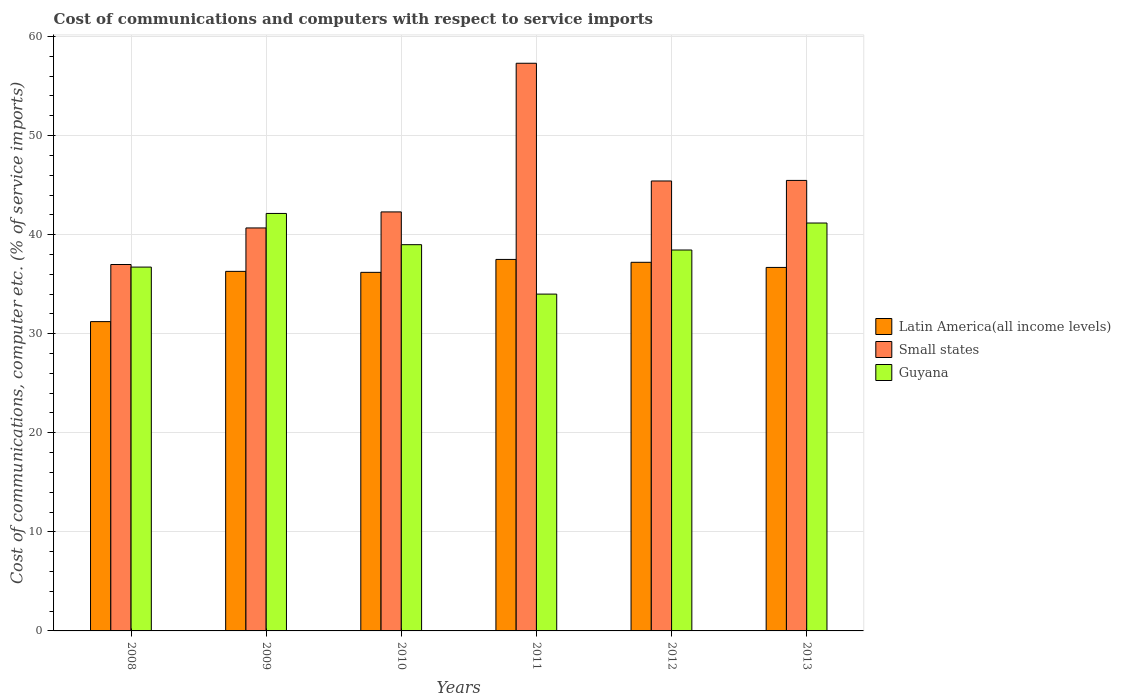How many different coloured bars are there?
Offer a very short reply. 3. How many bars are there on the 6th tick from the left?
Provide a short and direct response. 3. In how many cases, is the number of bars for a given year not equal to the number of legend labels?
Offer a terse response. 0. What is the cost of communications and computers in Guyana in 2013?
Offer a very short reply. 41.17. Across all years, what is the maximum cost of communications and computers in Latin America(all income levels)?
Ensure brevity in your answer.  37.5. Across all years, what is the minimum cost of communications and computers in Latin America(all income levels)?
Offer a very short reply. 31.22. In which year was the cost of communications and computers in Small states minimum?
Make the answer very short. 2008. What is the total cost of communications and computers in Small states in the graph?
Give a very brief answer. 268.16. What is the difference between the cost of communications and computers in Latin America(all income levels) in 2009 and that in 2011?
Your answer should be very brief. -1.2. What is the difference between the cost of communications and computers in Small states in 2012 and the cost of communications and computers in Guyana in 2013?
Your answer should be very brief. 4.24. What is the average cost of communications and computers in Latin America(all income levels) per year?
Offer a terse response. 35.85. In the year 2009, what is the difference between the cost of communications and computers in Latin America(all income levels) and cost of communications and computers in Guyana?
Make the answer very short. -5.85. In how many years, is the cost of communications and computers in Guyana greater than 10 %?
Offer a very short reply. 6. What is the ratio of the cost of communications and computers in Latin America(all income levels) in 2008 to that in 2011?
Give a very brief answer. 0.83. Is the cost of communications and computers in Guyana in 2010 less than that in 2011?
Make the answer very short. No. What is the difference between the highest and the second highest cost of communications and computers in Small states?
Offer a terse response. 11.83. What is the difference between the highest and the lowest cost of communications and computers in Guyana?
Offer a terse response. 8.14. In how many years, is the cost of communications and computers in Guyana greater than the average cost of communications and computers in Guyana taken over all years?
Your response must be concise. 3. Is the sum of the cost of communications and computers in Small states in 2011 and 2012 greater than the maximum cost of communications and computers in Latin America(all income levels) across all years?
Provide a succinct answer. Yes. What does the 1st bar from the left in 2009 represents?
Keep it short and to the point. Latin America(all income levels). What does the 3rd bar from the right in 2013 represents?
Keep it short and to the point. Latin America(all income levels). Is it the case that in every year, the sum of the cost of communications and computers in Latin America(all income levels) and cost of communications and computers in Small states is greater than the cost of communications and computers in Guyana?
Your answer should be very brief. Yes. Are all the bars in the graph horizontal?
Offer a terse response. No. How many years are there in the graph?
Your answer should be very brief. 6. Are the values on the major ticks of Y-axis written in scientific E-notation?
Offer a very short reply. No. How many legend labels are there?
Your answer should be very brief. 3. What is the title of the graph?
Offer a very short reply. Cost of communications and computers with respect to service imports. Does "Malaysia" appear as one of the legend labels in the graph?
Make the answer very short. No. What is the label or title of the X-axis?
Keep it short and to the point. Years. What is the label or title of the Y-axis?
Give a very brief answer. Cost of communications, computer etc. (% of service imports). What is the Cost of communications, computer etc. (% of service imports) in Latin America(all income levels) in 2008?
Make the answer very short. 31.22. What is the Cost of communications, computer etc. (% of service imports) in Small states in 2008?
Your answer should be compact. 36.99. What is the Cost of communications, computer etc. (% of service imports) in Guyana in 2008?
Offer a very short reply. 36.73. What is the Cost of communications, computer etc. (% of service imports) of Latin America(all income levels) in 2009?
Your answer should be very brief. 36.3. What is the Cost of communications, computer etc. (% of service imports) of Small states in 2009?
Provide a short and direct response. 40.68. What is the Cost of communications, computer etc. (% of service imports) of Guyana in 2009?
Ensure brevity in your answer.  42.14. What is the Cost of communications, computer etc. (% of service imports) of Latin America(all income levels) in 2010?
Provide a short and direct response. 36.2. What is the Cost of communications, computer etc. (% of service imports) in Small states in 2010?
Your answer should be very brief. 42.3. What is the Cost of communications, computer etc. (% of service imports) of Guyana in 2010?
Your answer should be very brief. 38.99. What is the Cost of communications, computer etc. (% of service imports) of Latin America(all income levels) in 2011?
Your response must be concise. 37.5. What is the Cost of communications, computer etc. (% of service imports) of Small states in 2011?
Your answer should be very brief. 57.3. What is the Cost of communications, computer etc. (% of service imports) of Guyana in 2011?
Your answer should be very brief. 34. What is the Cost of communications, computer etc. (% of service imports) in Latin America(all income levels) in 2012?
Your answer should be compact. 37.21. What is the Cost of communications, computer etc. (% of service imports) of Small states in 2012?
Your answer should be very brief. 45.42. What is the Cost of communications, computer etc. (% of service imports) in Guyana in 2012?
Provide a short and direct response. 38.45. What is the Cost of communications, computer etc. (% of service imports) in Latin America(all income levels) in 2013?
Ensure brevity in your answer.  36.69. What is the Cost of communications, computer etc. (% of service imports) of Small states in 2013?
Your answer should be very brief. 45.48. What is the Cost of communications, computer etc. (% of service imports) in Guyana in 2013?
Provide a succinct answer. 41.17. Across all years, what is the maximum Cost of communications, computer etc. (% of service imports) in Latin America(all income levels)?
Make the answer very short. 37.5. Across all years, what is the maximum Cost of communications, computer etc. (% of service imports) in Small states?
Make the answer very short. 57.3. Across all years, what is the maximum Cost of communications, computer etc. (% of service imports) in Guyana?
Provide a short and direct response. 42.14. Across all years, what is the minimum Cost of communications, computer etc. (% of service imports) in Latin America(all income levels)?
Keep it short and to the point. 31.22. Across all years, what is the minimum Cost of communications, computer etc. (% of service imports) in Small states?
Make the answer very short. 36.99. Across all years, what is the minimum Cost of communications, computer etc. (% of service imports) of Guyana?
Your response must be concise. 34. What is the total Cost of communications, computer etc. (% of service imports) of Latin America(all income levels) in the graph?
Provide a short and direct response. 215.12. What is the total Cost of communications, computer etc. (% of service imports) in Small states in the graph?
Offer a very short reply. 268.16. What is the total Cost of communications, computer etc. (% of service imports) in Guyana in the graph?
Your answer should be compact. 231.48. What is the difference between the Cost of communications, computer etc. (% of service imports) in Latin America(all income levels) in 2008 and that in 2009?
Make the answer very short. -5.07. What is the difference between the Cost of communications, computer etc. (% of service imports) of Small states in 2008 and that in 2009?
Provide a short and direct response. -3.69. What is the difference between the Cost of communications, computer etc. (% of service imports) in Guyana in 2008 and that in 2009?
Provide a short and direct response. -5.42. What is the difference between the Cost of communications, computer etc. (% of service imports) of Latin America(all income levels) in 2008 and that in 2010?
Offer a very short reply. -4.97. What is the difference between the Cost of communications, computer etc. (% of service imports) of Small states in 2008 and that in 2010?
Provide a succinct answer. -5.31. What is the difference between the Cost of communications, computer etc. (% of service imports) of Guyana in 2008 and that in 2010?
Your response must be concise. -2.26. What is the difference between the Cost of communications, computer etc. (% of service imports) of Latin America(all income levels) in 2008 and that in 2011?
Provide a short and direct response. -6.28. What is the difference between the Cost of communications, computer etc. (% of service imports) of Small states in 2008 and that in 2011?
Keep it short and to the point. -20.31. What is the difference between the Cost of communications, computer etc. (% of service imports) of Guyana in 2008 and that in 2011?
Make the answer very short. 2.73. What is the difference between the Cost of communications, computer etc. (% of service imports) of Latin America(all income levels) in 2008 and that in 2012?
Your answer should be very brief. -5.99. What is the difference between the Cost of communications, computer etc. (% of service imports) in Small states in 2008 and that in 2012?
Offer a terse response. -8.43. What is the difference between the Cost of communications, computer etc. (% of service imports) of Guyana in 2008 and that in 2012?
Your response must be concise. -1.72. What is the difference between the Cost of communications, computer etc. (% of service imports) of Latin America(all income levels) in 2008 and that in 2013?
Give a very brief answer. -5.47. What is the difference between the Cost of communications, computer etc. (% of service imports) of Small states in 2008 and that in 2013?
Provide a succinct answer. -8.49. What is the difference between the Cost of communications, computer etc. (% of service imports) of Guyana in 2008 and that in 2013?
Your answer should be compact. -4.45. What is the difference between the Cost of communications, computer etc. (% of service imports) in Latin America(all income levels) in 2009 and that in 2010?
Provide a short and direct response. 0.1. What is the difference between the Cost of communications, computer etc. (% of service imports) of Small states in 2009 and that in 2010?
Your response must be concise. -1.62. What is the difference between the Cost of communications, computer etc. (% of service imports) of Guyana in 2009 and that in 2010?
Provide a succinct answer. 3.15. What is the difference between the Cost of communications, computer etc. (% of service imports) in Latin America(all income levels) in 2009 and that in 2011?
Provide a succinct answer. -1.2. What is the difference between the Cost of communications, computer etc. (% of service imports) in Small states in 2009 and that in 2011?
Offer a terse response. -16.62. What is the difference between the Cost of communications, computer etc. (% of service imports) in Guyana in 2009 and that in 2011?
Make the answer very short. 8.14. What is the difference between the Cost of communications, computer etc. (% of service imports) of Latin America(all income levels) in 2009 and that in 2012?
Provide a short and direct response. -0.91. What is the difference between the Cost of communications, computer etc. (% of service imports) in Small states in 2009 and that in 2012?
Ensure brevity in your answer.  -4.74. What is the difference between the Cost of communications, computer etc. (% of service imports) in Guyana in 2009 and that in 2012?
Your answer should be very brief. 3.69. What is the difference between the Cost of communications, computer etc. (% of service imports) in Latin America(all income levels) in 2009 and that in 2013?
Provide a short and direct response. -0.4. What is the difference between the Cost of communications, computer etc. (% of service imports) in Small states in 2009 and that in 2013?
Offer a terse response. -4.8. What is the difference between the Cost of communications, computer etc. (% of service imports) of Guyana in 2009 and that in 2013?
Provide a short and direct response. 0.97. What is the difference between the Cost of communications, computer etc. (% of service imports) of Latin America(all income levels) in 2010 and that in 2011?
Provide a short and direct response. -1.3. What is the difference between the Cost of communications, computer etc. (% of service imports) of Small states in 2010 and that in 2011?
Your answer should be compact. -15.01. What is the difference between the Cost of communications, computer etc. (% of service imports) in Guyana in 2010 and that in 2011?
Offer a terse response. 4.99. What is the difference between the Cost of communications, computer etc. (% of service imports) of Latin America(all income levels) in 2010 and that in 2012?
Offer a terse response. -1.01. What is the difference between the Cost of communications, computer etc. (% of service imports) of Small states in 2010 and that in 2012?
Keep it short and to the point. -3.12. What is the difference between the Cost of communications, computer etc. (% of service imports) in Guyana in 2010 and that in 2012?
Your answer should be compact. 0.54. What is the difference between the Cost of communications, computer etc. (% of service imports) in Latin America(all income levels) in 2010 and that in 2013?
Your answer should be compact. -0.5. What is the difference between the Cost of communications, computer etc. (% of service imports) in Small states in 2010 and that in 2013?
Offer a very short reply. -3.18. What is the difference between the Cost of communications, computer etc. (% of service imports) of Guyana in 2010 and that in 2013?
Give a very brief answer. -2.19. What is the difference between the Cost of communications, computer etc. (% of service imports) in Latin America(all income levels) in 2011 and that in 2012?
Make the answer very short. 0.29. What is the difference between the Cost of communications, computer etc. (% of service imports) of Small states in 2011 and that in 2012?
Offer a very short reply. 11.88. What is the difference between the Cost of communications, computer etc. (% of service imports) of Guyana in 2011 and that in 2012?
Your answer should be compact. -4.45. What is the difference between the Cost of communications, computer etc. (% of service imports) of Latin America(all income levels) in 2011 and that in 2013?
Keep it short and to the point. 0.81. What is the difference between the Cost of communications, computer etc. (% of service imports) of Small states in 2011 and that in 2013?
Provide a short and direct response. 11.83. What is the difference between the Cost of communications, computer etc. (% of service imports) in Guyana in 2011 and that in 2013?
Your answer should be compact. -7.17. What is the difference between the Cost of communications, computer etc. (% of service imports) of Latin America(all income levels) in 2012 and that in 2013?
Your response must be concise. 0.52. What is the difference between the Cost of communications, computer etc. (% of service imports) in Small states in 2012 and that in 2013?
Provide a short and direct response. -0.06. What is the difference between the Cost of communications, computer etc. (% of service imports) of Guyana in 2012 and that in 2013?
Your answer should be compact. -2.72. What is the difference between the Cost of communications, computer etc. (% of service imports) in Latin America(all income levels) in 2008 and the Cost of communications, computer etc. (% of service imports) in Small states in 2009?
Keep it short and to the point. -9.46. What is the difference between the Cost of communications, computer etc. (% of service imports) in Latin America(all income levels) in 2008 and the Cost of communications, computer etc. (% of service imports) in Guyana in 2009?
Provide a short and direct response. -10.92. What is the difference between the Cost of communications, computer etc. (% of service imports) of Small states in 2008 and the Cost of communications, computer etc. (% of service imports) of Guyana in 2009?
Make the answer very short. -5.15. What is the difference between the Cost of communications, computer etc. (% of service imports) in Latin America(all income levels) in 2008 and the Cost of communications, computer etc. (% of service imports) in Small states in 2010?
Your response must be concise. -11.07. What is the difference between the Cost of communications, computer etc. (% of service imports) in Latin America(all income levels) in 2008 and the Cost of communications, computer etc. (% of service imports) in Guyana in 2010?
Make the answer very short. -7.77. What is the difference between the Cost of communications, computer etc. (% of service imports) of Small states in 2008 and the Cost of communications, computer etc. (% of service imports) of Guyana in 2010?
Your answer should be compact. -2. What is the difference between the Cost of communications, computer etc. (% of service imports) of Latin America(all income levels) in 2008 and the Cost of communications, computer etc. (% of service imports) of Small states in 2011?
Your answer should be compact. -26.08. What is the difference between the Cost of communications, computer etc. (% of service imports) of Latin America(all income levels) in 2008 and the Cost of communications, computer etc. (% of service imports) of Guyana in 2011?
Your answer should be very brief. -2.78. What is the difference between the Cost of communications, computer etc. (% of service imports) in Small states in 2008 and the Cost of communications, computer etc. (% of service imports) in Guyana in 2011?
Offer a terse response. 2.99. What is the difference between the Cost of communications, computer etc. (% of service imports) of Latin America(all income levels) in 2008 and the Cost of communications, computer etc. (% of service imports) of Small states in 2012?
Your answer should be compact. -14.2. What is the difference between the Cost of communications, computer etc. (% of service imports) of Latin America(all income levels) in 2008 and the Cost of communications, computer etc. (% of service imports) of Guyana in 2012?
Offer a terse response. -7.23. What is the difference between the Cost of communications, computer etc. (% of service imports) of Small states in 2008 and the Cost of communications, computer etc. (% of service imports) of Guyana in 2012?
Offer a very short reply. -1.46. What is the difference between the Cost of communications, computer etc. (% of service imports) in Latin America(all income levels) in 2008 and the Cost of communications, computer etc. (% of service imports) in Small states in 2013?
Offer a terse response. -14.25. What is the difference between the Cost of communications, computer etc. (% of service imports) of Latin America(all income levels) in 2008 and the Cost of communications, computer etc. (% of service imports) of Guyana in 2013?
Your response must be concise. -9.95. What is the difference between the Cost of communications, computer etc. (% of service imports) in Small states in 2008 and the Cost of communications, computer etc. (% of service imports) in Guyana in 2013?
Your response must be concise. -4.19. What is the difference between the Cost of communications, computer etc. (% of service imports) of Latin America(all income levels) in 2009 and the Cost of communications, computer etc. (% of service imports) of Small states in 2010?
Make the answer very short. -6. What is the difference between the Cost of communications, computer etc. (% of service imports) in Latin America(all income levels) in 2009 and the Cost of communications, computer etc. (% of service imports) in Guyana in 2010?
Your answer should be compact. -2.69. What is the difference between the Cost of communications, computer etc. (% of service imports) of Small states in 2009 and the Cost of communications, computer etc. (% of service imports) of Guyana in 2010?
Provide a short and direct response. 1.69. What is the difference between the Cost of communications, computer etc. (% of service imports) of Latin America(all income levels) in 2009 and the Cost of communications, computer etc. (% of service imports) of Small states in 2011?
Ensure brevity in your answer.  -21.01. What is the difference between the Cost of communications, computer etc. (% of service imports) of Latin America(all income levels) in 2009 and the Cost of communications, computer etc. (% of service imports) of Guyana in 2011?
Offer a very short reply. 2.3. What is the difference between the Cost of communications, computer etc. (% of service imports) in Small states in 2009 and the Cost of communications, computer etc. (% of service imports) in Guyana in 2011?
Give a very brief answer. 6.68. What is the difference between the Cost of communications, computer etc. (% of service imports) in Latin America(all income levels) in 2009 and the Cost of communications, computer etc. (% of service imports) in Small states in 2012?
Provide a short and direct response. -9.12. What is the difference between the Cost of communications, computer etc. (% of service imports) in Latin America(all income levels) in 2009 and the Cost of communications, computer etc. (% of service imports) in Guyana in 2012?
Provide a succinct answer. -2.15. What is the difference between the Cost of communications, computer etc. (% of service imports) in Small states in 2009 and the Cost of communications, computer etc. (% of service imports) in Guyana in 2012?
Your response must be concise. 2.23. What is the difference between the Cost of communications, computer etc. (% of service imports) in Latin America(all income levels) in 2009 and the Cost of communications, computer etc. (% of service imports) in Small states in 2013?
Your answer should be compact. -9.18. What is the difference between the Cost of communications, computer etc. (% of service imports) of Latin America(all income levels) in 2009 and the Cost of communications, computer etc. (% of service imports) of Guyana in 2013?
Make the answer very short. -4.88. What is the difference between the Cost of communications, computer etc. (% of service imports) of Small states in 2009 and the Cost of communications, computer etc. (% of service imports) of Guyana in 2013?
Give a very brief answer. -0.5. What is the difference between the Cost of communications, computer etc. (% of service imports) in Latin America(all income levels) in 2010 and the Cost of communications, computer etc. (% of service imports) in Small states in 2011?
Give a very brief answer. -21.11. What is the difference between the Cost of communications, computer etc. (% of service imports) of Latin America(all income levels) in 2010 and the Cost of communications, computer etc. (% of service imports) of Guyana in 2011?
Offer a very short reply. 2.2. What is the difference between the Cost of communications, computer etc. (% of service imports) in Small states in 2010 and the Cost of communications, computer etc. (% of service imports) in Guyana in 2011?
Provide a short and direct response. 8.3. What is the difference between the Cost of communications, computer etc. (% of service imports) in Latin America(all income levels) in 2010 and the Cost of communications, computer etc. (% of service imports) in Small states in 2012?
Offer a terse response. -9.22. What is the difference between the Cost of communications, computer etc. (% of service imports) of Latin America(all income levels) in 2010 and the Cost of communications, computer etc. (% of service imports) of Guyana in 2012?
Your response must be concise. -2.25. What is the difference between the Cost of communications, computer etc. (% of service imports) of Small states in 2010 and the Cost of communications, computer etc. (% of service imports) of Guyana in 2012?
Ensure brevity in your answer.  3.85. What is the difference between the Cost of communications, computer etc. (% of service imports) of Latin America(all income levels) in 2010 and the Cost of communications, computer etc. (% of service imports) of Small states in 2013?
Your answer should be compact. -9.28. What is the difference between the Cost of communications, computer etc. (% of service imports) in Latin America(all income levels) in 2010 and the Cost of communications, computer etc. (% of service imports) in Guyana in 2013?
Give a very brief answer. -4.98. What is the difference between the Cost of communications, computer etc. (% of service imports) of Small states in 2010 and the Cost of communications, computer etc. (% of service imports) of Guyana in 2013?
Ensure brevity in your answer.  1.12. What is the difference between the Cost of communications, computer etc. (% of service imports) in Latin America(all income levels) in 2011 and the Cost of communications, computer etc. (% of service imports) in Small states in 2012?
Give a very brief answer. -7.92. What is the difference between the Cost of communications, computer etc. (% of service imports) of Latin America(all income levels) in 2011 and the Cost of communications, computer etc. (% of service imports) of Guyana in 2012?
Ensure brevity in your answer.  -0.95. What is the difference between the Cost of communications, computer etc. (% of service imports) in Small states in 2011 and the Cost of communications, computer etc. (% of service imports) in Guyana in 2012?
Keep it short and to the point. 18.85. What is the difference between the Cost of communications, computer etc. (% of service imports) of Latin America(all income levels) in 2011 and the Cost of communications, computer etc. (% of service imports) of Small states in 2013?
Give a very brief answer. -7.98. What is the difference between the Cost of communications, computer etc. (% of service imports) in Latin America(all income levels) in 2011 and the Cost of communications, computer etc. (% of service imports) in Guyana in 2013?
Your answer should be very brief. -3.67. What is the difference between the Cost of communications, computer etc. (% of service imports) in Small states in 2011 and the Cost of communications, computer etc. (% of service imports) in Guyana in 2013?
Offer a terse response. 16.13. What is the difference between the Cost of communications, computer etc. (% of service imports) of Latin America(all income levels) in 2012 and the Cost of communications, computer etc. (% of service imports) of Small states in 2013?
Ensure brevity in your answer.  -8.27. What is the difference between the Cost of communications, computer etc. (% of service imports) of Latin America(all income levels) in 2012 and the Cost of communications, computer etc. (% of service imports) of Guyana in 2013?
Give a very brief answer. -3.97. What is the difference between the Cost of communications, computer etc. (% of service imports) in Small states in 2012 and the Cost of communications, computer etc. (% of service imports) in Guyana in 2013?
Your answer should be compact. 4.24. What is the average Cost of communications, computer etc. (% of service imports) of Latin America(all income levels) per year?
Offer a very short reply. 35.85. What is the average Cost of communications, computer etc. (% of service imports) in Small states per year?
Your response must be concise. 44.69. What is the average Cost of communications, computer etc. (% of service imports) in Guyana per year?
Make the answer very short. 38.58. In the year 2008, what is the difference between the Cost of communications, computer etc. (% of service imports) in Latin America(all income levels) and Cost of communications, computer etc. (% of service imports) in Small states?
Your answer should be compact. -5.77. In the year 2008, what is the difference between the Cost of communications, computer etc. (% of service imports) in Latin America(all income levels) and Cost of communications, computer etc. (% of service imports) in Guyana?
Ensure brevity in your answer.  -5.5. In the year 2008, what is the difference between the Cost of communications, computer etc. (% of service imports) in Small states and Cost of communications, computer etc. (% of service imports) in Guyana?
Make the answer very short. 0.26. In the year 2009, what is the difference between the Cost of communications, computer etc. (% of service imports) in Latin America(all income levels) and Cost of communications, computer etc. (% of service imports) in Small states?
Give a very brief answer. -4.38. In the year 2009, what is the difference between the Cost of communications, computer etc. (% of service imports) in Latin America(all income levels) and Cost of communications, computer etc. (% of service imports) in Guyana?
Provide a succinct answer. -5.85. In the year 2009, what is the difference between the Cost of communications, computer etc. (% of service imports) of Small states and Cost of communications, computer etc. (% of service imports) of Guyana?
Give a very brief answer. -1.46. In the year 2010, what is the difference between the Cost of communications, computer etc. (% of service imports) in Latin America(all income levels) and Cost of communications, computer etc. (% of service imports) in Small states?
Your answer should be compact. -6.1. In the year 2010, what is the difference between the Cost of communications, computer etc. (% of service imports) of Latin America(all income levels) and Cost of communications, computer etc. (% of service imports) of Guyana?
Give a very brief answer. -2.79. In the year 2010, what is the difference between the Cost of communications, computer etc. (% of service imports) in Small states and Cost of communications, computer etc. (% of service imports) in Guyana?
Keep it short and to the point. 3.31. In the year 2011, what is the difference between the Cost of communications, computer etc. (% of service imports) of Latin America(all income levels) and Cost of communications, computer etc. (% of service imports) of Small states?
Your answer should be compact. -19.8. In the year 2011, what is the difference between the Cost of communications, computer etc. (% of service imports) of Latin America(all income levels) and Cost of communications, computer etc. (% of service imports) of Guyana?
Provide a succinct answer. 3.5. In the year 2011, what is the difference between the Cost of communications, computer etc. (% of service imports) of Small states and Cost of communications, computer etc. (% of service imports) of Guyana?
Offer a very short reply. 23.3. In the year 2012, what is the difference between the Cost of communications, computer etc. (% of service imports) in Latin America(all income levels) and Cost of communications, computer etc. (% of service imports) in Small states?
Your response must be concise. -8.21. In the year 2012, what is the difference between the Cost of communications, computer etc. (% of service imports) in Latin America(all income levels) and Cost of communications, computer etc. (% of service imports) in Guyana?
Your response must be concise. -1.24. In the year 2012, what is the difference between the Cost of communications, computer etc. (% of service imports) in Small states and Cost of communications, computer etc. (% of service imports) in Guyana?
Ensure brevity in your answer.  6.97. In the year 2013, what is the difference between the Cost of communications, computer etc. (% of service imports) of Latin America(all income levels) and Cost of communications, computer etc. (% of service imports) of Small states?
Provide a short and direct response. -8.78. In the year 2013, what is the difference between the Cost of communications, computer etc. (% of service imports) in Latin America(all income levels) and Cost of communications, computer etc. (% of service imports) in Guyana?
Your response must be concise. -4.48. In the year 2013, what is the difference between the Cost of communications, computer etc. (% of service imports) of Small states and Cost of communications, computer etc. (% of service imports) of Guyana?
Make the answer very short. 4.3. What is the ratio of the Cost of communications, computer etc. (% of service imports) of Latin America(all income levels) in 2008 to that in 2009?
Offer a very short reply. 0.86. What is the ratio of the Cost of communications, computer etc. (% of service imports) of Small states in 2008 to that in 2009?
Ensure brevity in your answer.  0.91. What is the ratio of the Cost of communications, computer etc. (% of service imports) in Guyana in 2008 to that in 2009?
Make the answer very short. 0.87. What is the ratio of the Cost of communications, computer etc. (% of service imports) of Latin America(all income levels) in 2008 to that in 2010?
Your answer should be very brief. 0.86. What is the ratio of the Cost of communications, computer etc. (% of service imports) in Small states in 2008 to that in 2010?
Your answer should be compact. 0.87. What is the ratio of the Cost of communications, computer etc. (% of service imports) of Guyana in 2008 to that in 2010?
Give a very brief answer. 0.94. What is the ratio of the Cost of communications, computer etc. (% of service imports) in Latin America(all income levels) in 2008 to that in 2011?
Your response must be concise. 0.83. What is the ratio of the Cost of communications, computer etc. (% of service imports) of Small states in 2008 to that in 2011?
Make the answer very short. 0.65. What is the ratio of the Cost of communications, computer etc. (% of service imports) of Guyana in 2008 to that in 2011?
Your response must be concise. 1.08. What is the ratio of the Cost of communications, computer etc. (% of service imports) in Latin America(all income levels) in 2008 to that in 2012?
Ensure brevity in your answer.  0.84. What is the ratio of the Cost of communications, computer etc. (% of service imports) in Small states in 2008 to that in 2012?
Provide a short and direct response. 0.81. What is the ratio of the Cost of communications, computer etc. (% of service imports) in Guyana in 2008 to that in 2012?
Offer a very short reply. 0.96. What is the ratio of the Cost of communications, computer etc. (% of service imports) in Latin America(all income levels) in 2008 to that in 2013?
Your response must be concise. 0.85. What is the ratio of the Cost of communications, computer etc. (% of service imports) of Small states in 2008 to that in 2013?
Ensure brevity in your answer.  0.81. What is the ratio of the Cost of communications, computer etc. (% of service imports) in Guyana in 2008 to that in 2013?
Your answer should be compact. 0.89. What is the ratio of the Cost of communications, computer etc. (% of service imports) of Latin America(all income levels) in 2009 to that in 2010?
Keep it short and to the point. 1. What is the ratio of the Cost of communications, computer etc. (% of service imports) in Small states in 2009 to that in 2010?
Provide a succinct answer. 0.96. What is the ratio of the Cost of communications, computer etc. (% of service imports) of Guyana in 2009 to that in 2010?
Provide a short and direct response. 1.08. What is the ratio of the Cost of communications, computer etc. (% of service imports) of Latin America(all income levels) in 2009 to that in 2011?
Ensure brevity in your answer.  0.97. What is the ratio of the Cost of communications, computer etc. (% of service imports) of Small states in 2009 to that in 2011?
Provide a short and direct response. 0.71. What is the ratio of the Cost of communications, computer etc. (% of service imports) of Guyana in 2009 to that in 2011?
Your answer should be very brief. 1.24. What is the ratio of the Cost of communications, computer etc. (% of service imports) of Latin America(all income levels) in 2009 to that in 2012?
Provide a short and direct response. 0.98. What is the ratio of the Cost of communications, computer etc. (% of service imports) in Small states in 2009 to that in 2012?
Provide a short and direct response. 0.9. What is the ratio of the Cost of communications, computer etc. (% of service imports) of Guyana in 2009 to that in 2012?
Your response must be concise. 1.1. What is the ratio of the Cost of communications, computer etc. (% of service imports) of Latin America(all income levels) in 2009 to that in 2013?
Give a very brief answer. 0.99. What is the ratio of the Cost of communications, computer etc. (% of service imports) of Small states in 2009 to that in 2013?
Ensure brevity in your answer.  0.89. What is the ratio of the Cost of communications, computer etc. (% of service imports) in Guyana in 2009 to that in 2013?
Provide a succinct answer. 1.02. What is the ratio of the Cost of communications, computer etc. (% of service imports) in Latin America(all income levels) in 2010 to that in 2011?
Your answer should be compact. 0.97. What is the ratio of the Cost of communications, computer etc. (% of service imports) of Small states in 2010 to that in 2011?
Offer a very short reply. 0.74. What is the ratio of the Cost of communications, computer etc. (% of service imports) in Guyana in 2010 to that in 2011?
Your answer should be very brief. 1.15. What is the ratio of the Cost of communications, computer etc. (% of service imports) of Latin America(all income levels) in 2010 to that in 2012?
Offer a terse response. 0.97. What is the ratio of the Cost of communications, computer etc. (% of service imports) of Small states in 2010 to that in 2012?
Your answer should be very brief. 0.93. What is the ratio of the Cost of communications, computer etc. (% of service imports) in Guyana in 2010 to that in 2012?
Give a very brief answer. 1.01. What is the ratio of the Cost of communications, computer etc. (% of service imports) of Latin America(all income levels) in 2010 to that in 2013?
Your response must be concise. 0.99. What is the ratio of the Cost of communications, computer etc. (% of service imports) of Small states in 2010 to that in 2013?
Ensure brevity in your answer.  0.93. What is the ratio of the Cost of communications, computer etc. (% of service imports) in Guyana in 2010 to that in 2013?
Offer a terse response. 0.95. What is the ratio of the Cost of communications, computer etc. (% of service imports) in Small states in 2011 to that in 2012?
Make the answer very short. 1.26. What is the ratio of the Cost of communications, computer etc. (% of service imports) of Guyana in 2011 to that in 2012?
Make the answer very short. 0.88. What is the ratio of the Cost of communications, computer etc. (% of service imports) in Latin America(all income levels) in 2011 to that in 2013?
Your response must be concise. 1.02. What is the ratio of the Cost of communications, computer etc. (% of service imports) in Small states in 2011 to that in 2013?
Keep it short and to the point. 1.26. What is the ratio of the Cost of communications, computer etc. (% of service imports) of Guyana in 2011 to that in 2013?
Provide a succinct answer. 0.83. What is the ratio of the Cost of communications, computer etc. (% of service imports) in Latin America(all income levels) in 2012 to that in 2013?
Offer a terse response. 1.01. What is the ratio of the Cost of communications, computer etc. (% of service imports) of Guyana in 2012 to that in 2013?
Give a very brief answer. 0.93. What is the difference between the highest and the second highest Cost of communications, computer etc. (% of service imports) of Latin America(all income levels)?
Give a very brief answer. 0.29. What is the difference between the highest and the second highest Cost of communications, computer etc. (% of service imports) of Small states?
Your answer should be very brief. 11.83. What is the difference between the highest and the second highest Cost of communications, computer etc. (% of service imports) of Guyana?
Provide a short and direct response. 0.97. What is the difference between the highest and the lowest Cost of communications, computer etc. (% of service imports) in Latin America(all income levels)?
Ensure brevity in your answer.  6.28. What is the difference between the highest and the lowest Cost of communications, computer etc. (% of service imports) in Small states?
Your answer should be very brief. 20.31. What is the difference between the highest and the lowest Cost of communications, computer etc. (% of service imports) in Guyana?
Ensure brevity in your answer.  8.14. 